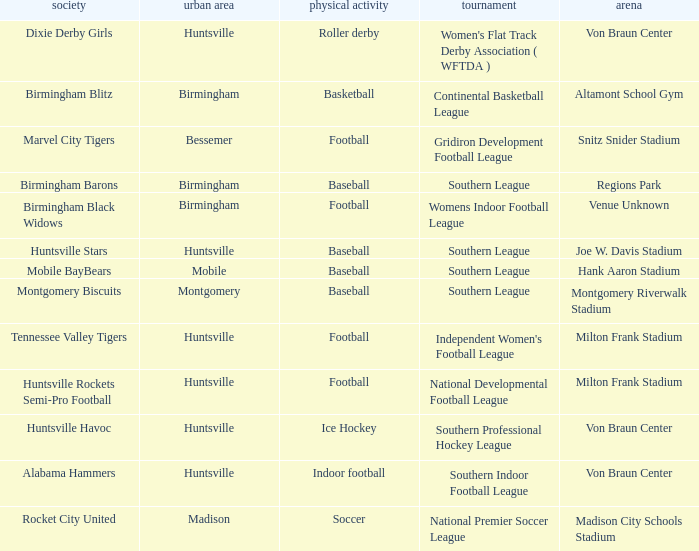Which venue hosted the Gridiron Development Football League? Snitz Snider Stadium. 